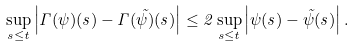Convert formula to latex. <formula><loc_0><loc_0><loc_500><loc_500>\sup _ { s \leq t } \left | \Gamma ( \psi ) ( s ) - \Gamma ( \tilde { \psi } ) ( s ) \right | \leq 2 \sup _ { s \leq t } \left | \psi ( s ) - \tilde { \psi } ( s ) \right | .</formula> 